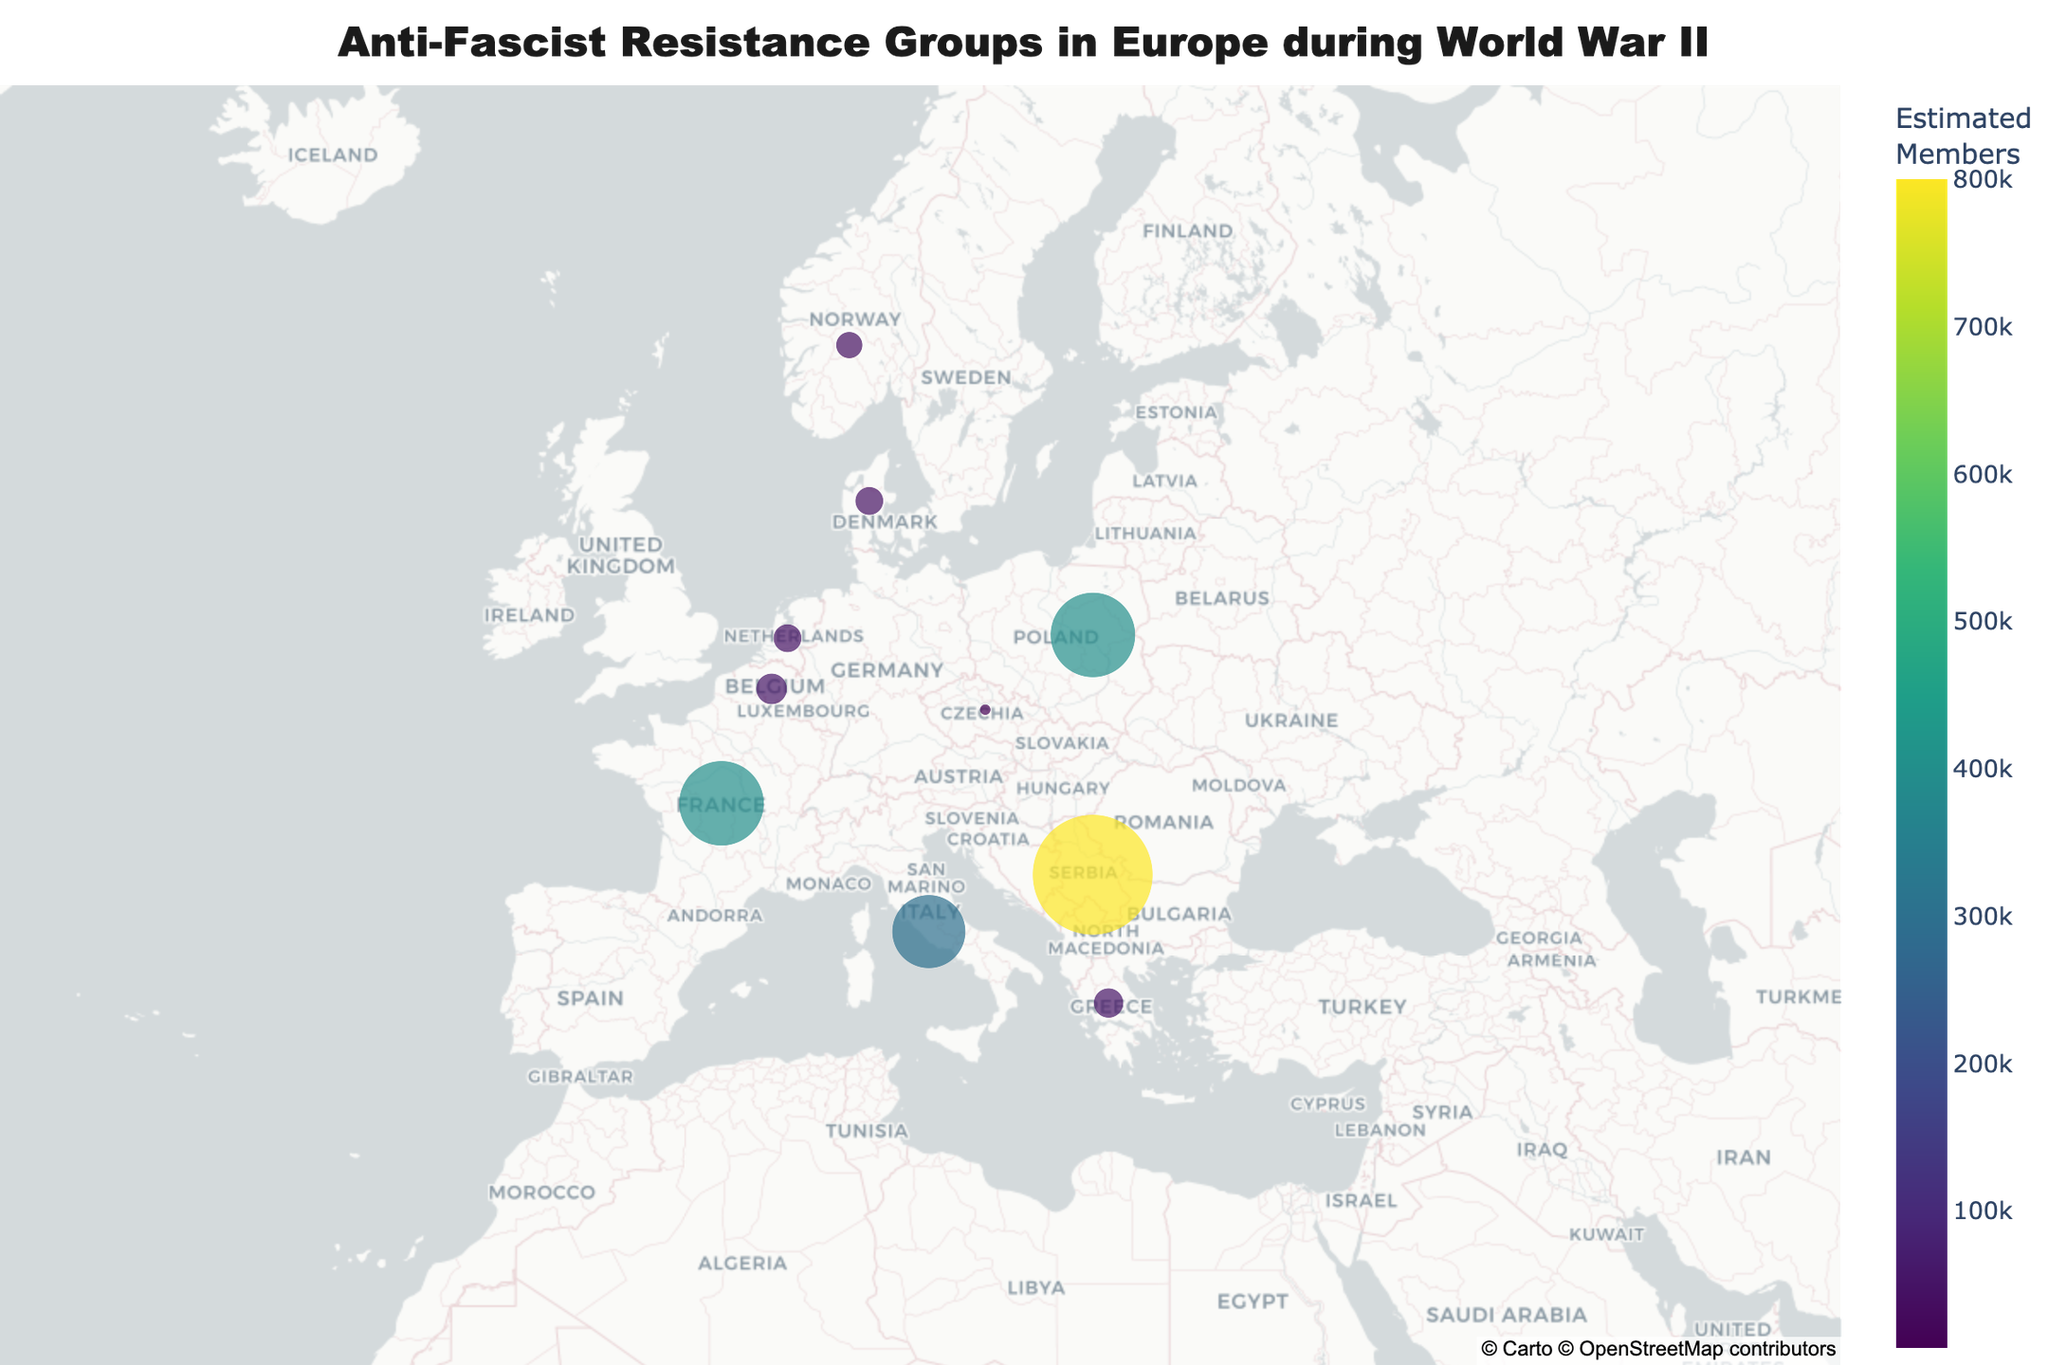How many countries are plotted on the map? By observing the figure, count the number of distinct data points, each representing a country.
Answer: 10 Which country has the largest anti-fascist resistance group? Look for the data point with the largest size on the map, as size represents the number of estimated members.
Answer: Yugoslavia Which two countries have the same estimated number of members in their resistance groups? Identify the countries with equal-sized markers by looking at the hover data.
Answer: France and Poland What is the title of the map? By reading the text at the top of the map.
Answer: Anti-Fascist Resistance Groups in Europe during World War II What color scale is used to represent the estimated members? Observe the gradient color bar, which should reflect the color scale used on the map.
Answer: Viridis Which country has the smallest resistance group, and how many estimated members are there? Find the smallest data point and check the hover data for details.
Answer: Czechoslovakia, 7000 What is the total number of estimated resistance group members in Italy and Greece combined? Sum the number of estimated members: 300,000 (Italy) + 50,000 (Greece) = 350,000.
Answer: 350,000 Rank the countries by the size of their resistance groups from highest to lowest. Compare the sizes of the data points and their hover data, then list them in descending order.
Answer: Yugoslavia, France & Poland (tied), Italy, Belgium, Greece, Denmark & Netherlands (tied), Norway, Czechoslovakia Which countries' resistance groups are displayed in a green color? Examine the color of the markers representing each resistance group. According to the color gradient, groups with middle-to-low size might be green.
Answer: Greece, Denmark, Netherlands Which countries' resistance groups have more than 300,000 members? Identify the countries with data points larger than the marker size that represents 300,000 members.
Answer: Yugoslavia, France, Poland, Italy 